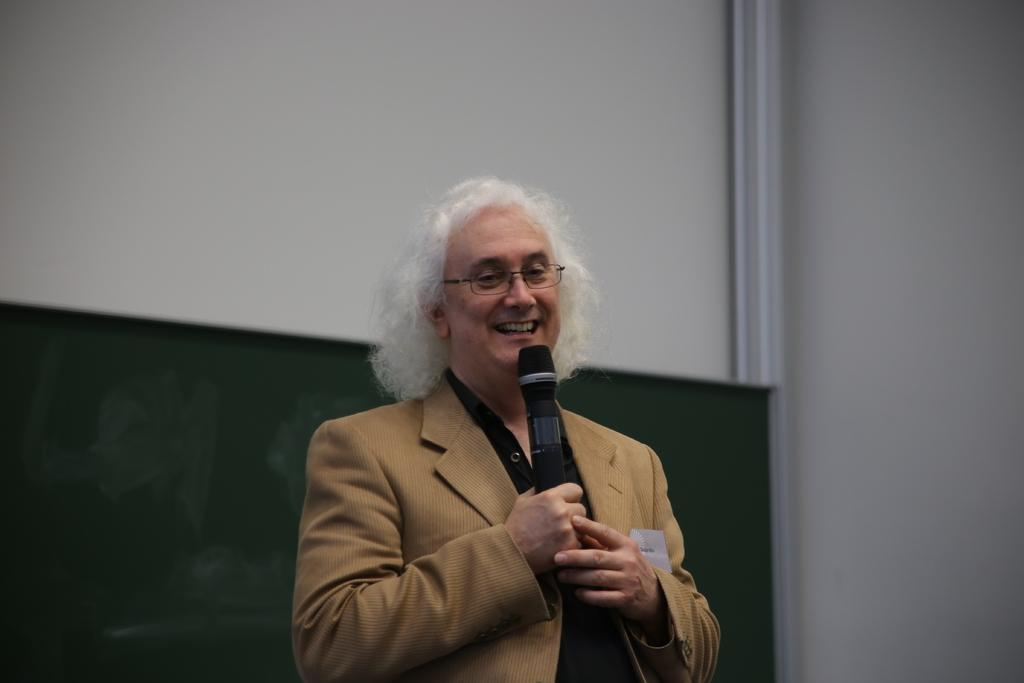What is the main subject of the image? The main subject of the image is a man. What is the man doing in the image? The man is standing and holding a microphone in his hand. Can you describe the man's appearance? The man is wearing spectacles and has a smile on his face. What can be seen in the background of the image? There is a wall in the background of the image. What type of fact is the man discussing in the image? There is no indication in the image that the man is discussing a fact, as he is holding a microphone but not speaking. Can you tell me how many governors are present in the image? There are no governors present in the image; it features a man holding a microphone. What type of bat is flying in the image? There is no bat present in the image; it features a man holding a microphone in front of a wall. 